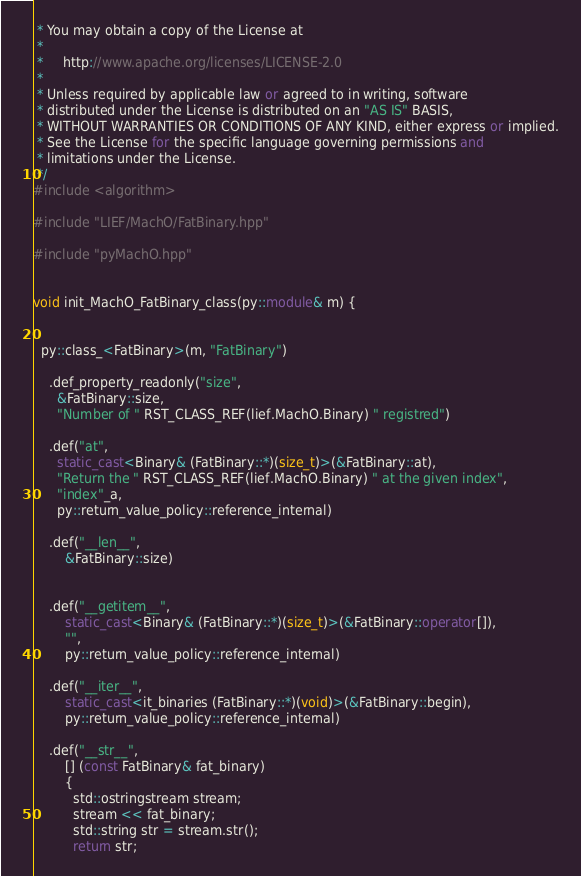<code> <loc_0><loc_0><loc_500><loc_500><_C++_> * You may obtain a copy of the License at
 *
 *     http://www.apache.org/licenses/LICENSE-2.0
 *
 * Unless required by applicable law or agreed to in writing, software
 * distributed under the License is distributed on an "AS IS" BASIS,
 * WITHOUT WARRANTIES OR CONDITIONS OF ANY KIND, either express or implied.
 * See the License for the specific language governing permissions and
 * limitations under the License.
 */
#include <algorithm>

#include "LIEF/MachO/FatBinary.hpp"

#include "pyMachO.hpp"


void init_MachO_FatBinary_class(py::module& m) {


  py::class_<FatBinary>(m, "FatBinary")

    .def_property_readonly("size",
      &FatBinary::size,
      "Number of " RST_CLASS_REF(lief.MachO.Binary) " registred")

    .def("at",
      static_cast<Binary& (FatBinary::*)(size_t)>(&FatBinary::at),
      "Return the " RST_CLASS_REF(lief.MachO.Binary) " at the given index",
      "index"_a,
      py::return_value_policy::reference_internal)

    .def("__len__",
        &FatBinary::size)


    .def("__getitem__",
        static_cast<Binary& (FatBinary::*)(size_t)>(&FatBinary::operator[]),
        "",
        py::return_value_policy::reference_internal)

    .def("__iter__",
        static_cast<it_binaries (FatBinary::*)(void)>(&FatBinary::begin),
        py::return_value_policy::reference_internal)

    .def("__str__",
        [] (const FatBinary& fat_binary)
        {
          std::ostringstream stream;
          stream << fat_binary;
          std::string str = stream.str();
          return str;</code> 